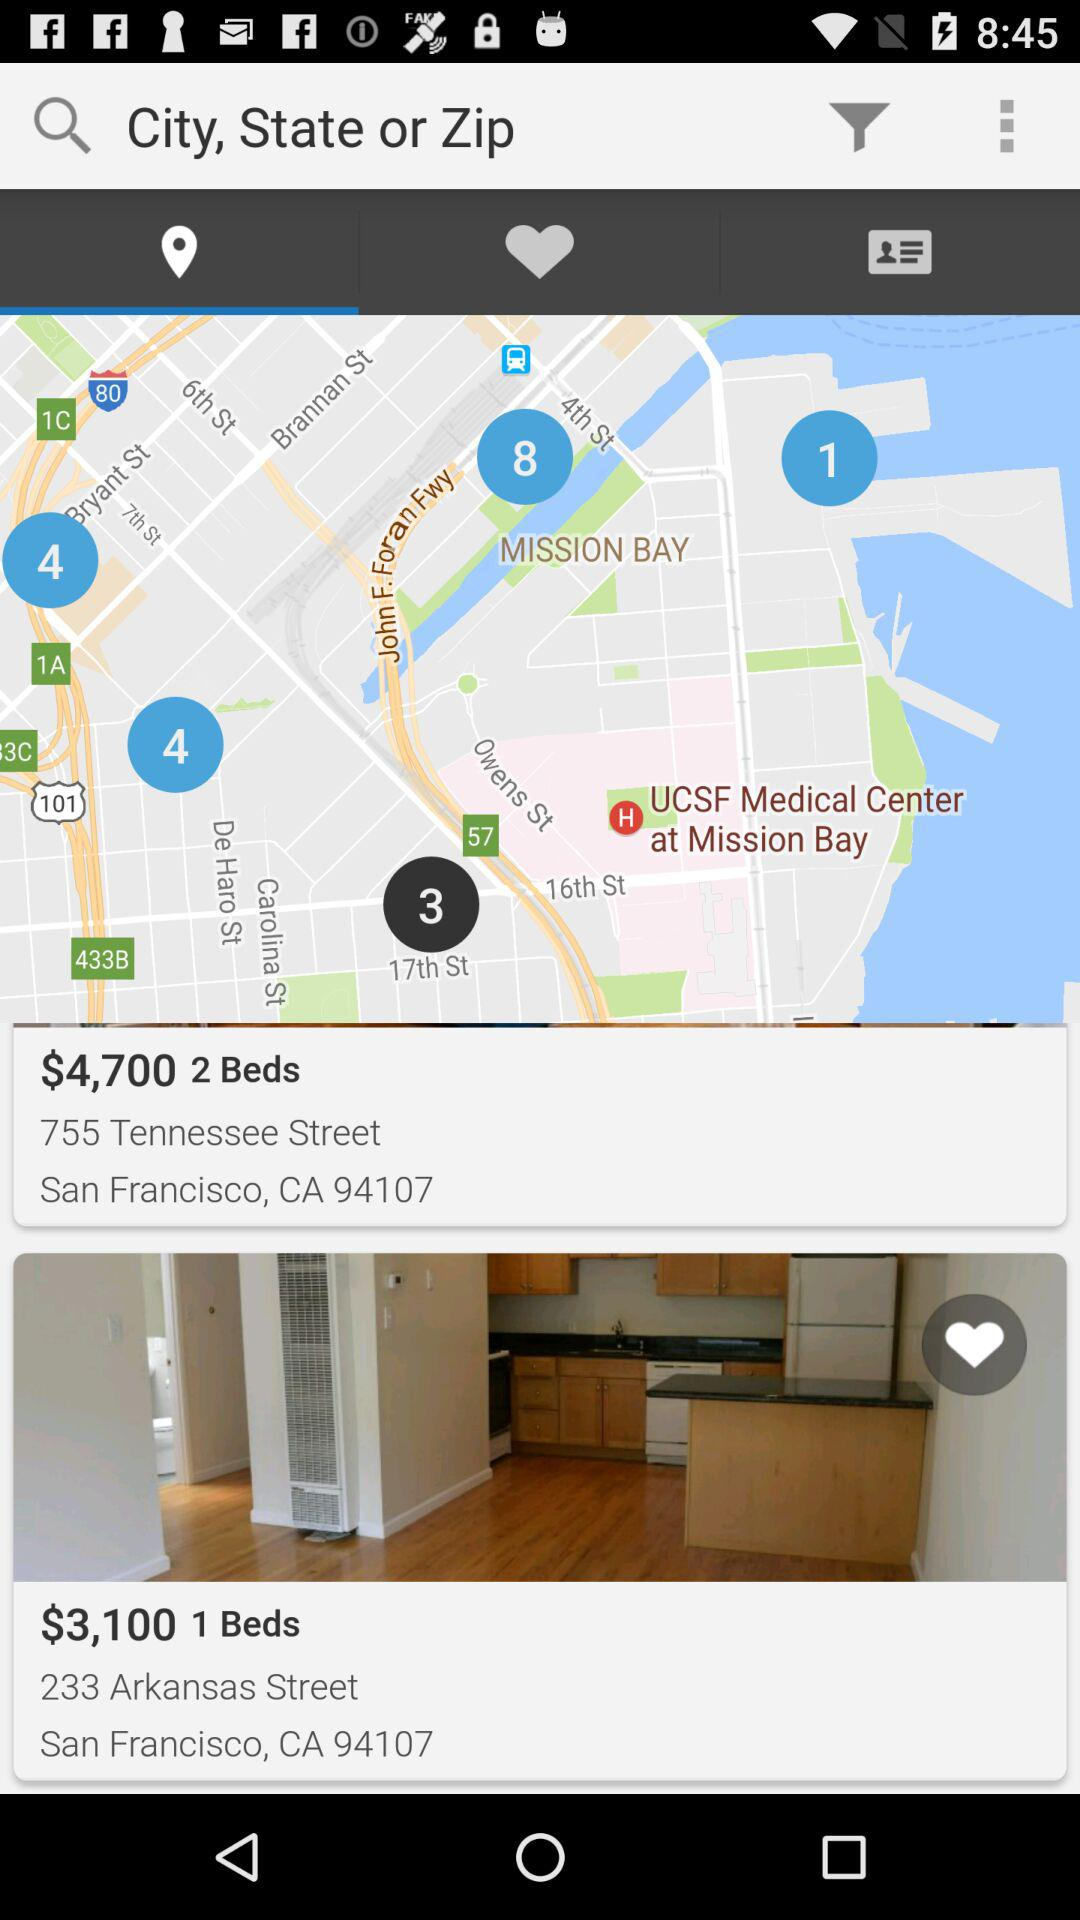What is the price of a single bed at 233 Arkansas Street? The price is $3,100. 